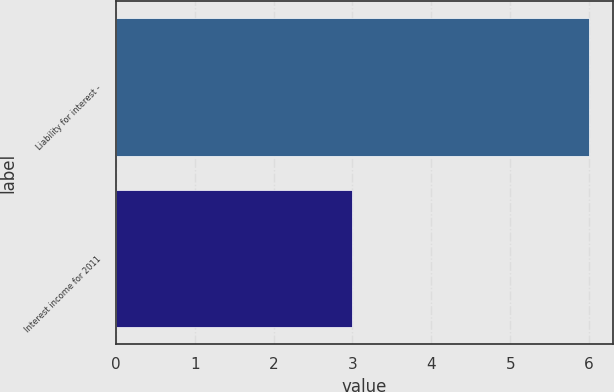<chart> <loc_0><loc_0><loc_500><loc_500><bar_chart><fcel>Liability for interest -<fcel>Interest income for 2011<nl><fcel>6<fcel>3<nl></chart> 